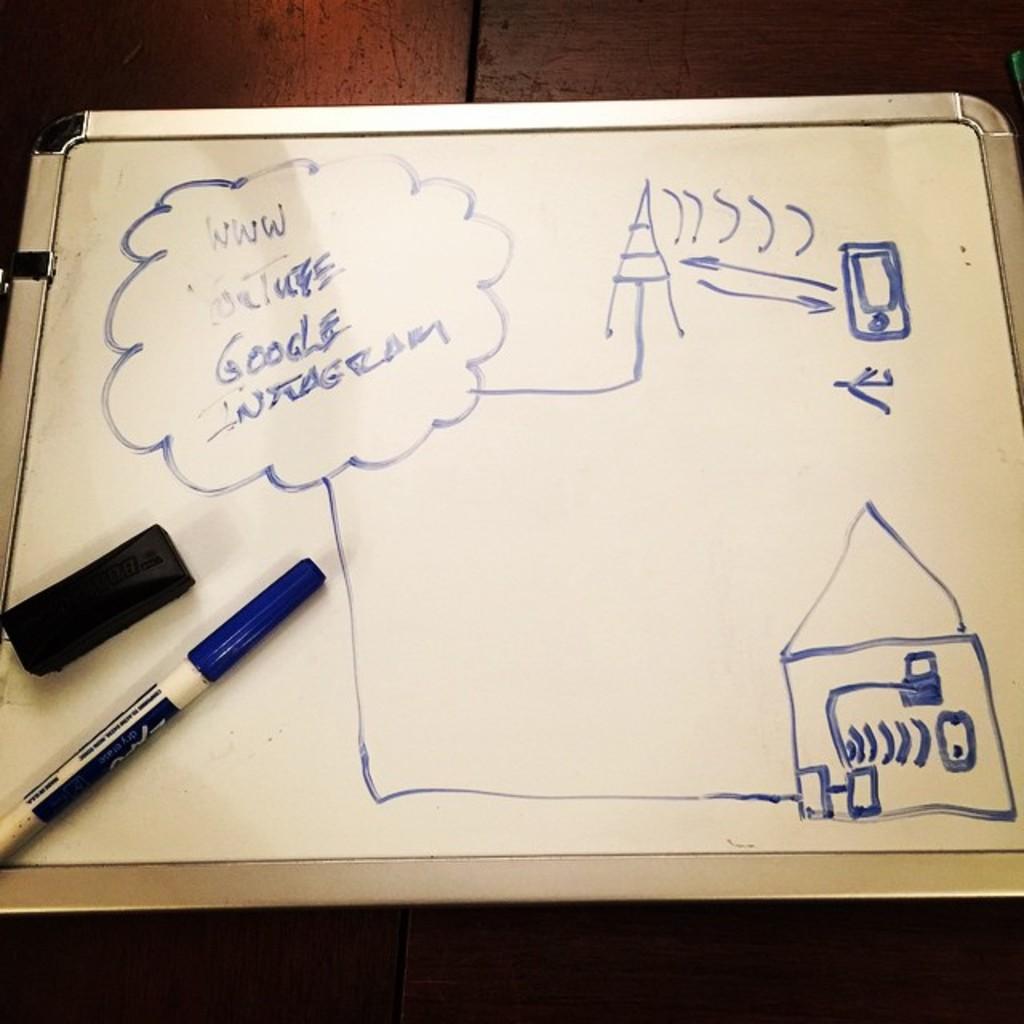What is the first website listed?
Ensure brevity in your answer.  Youtube. 